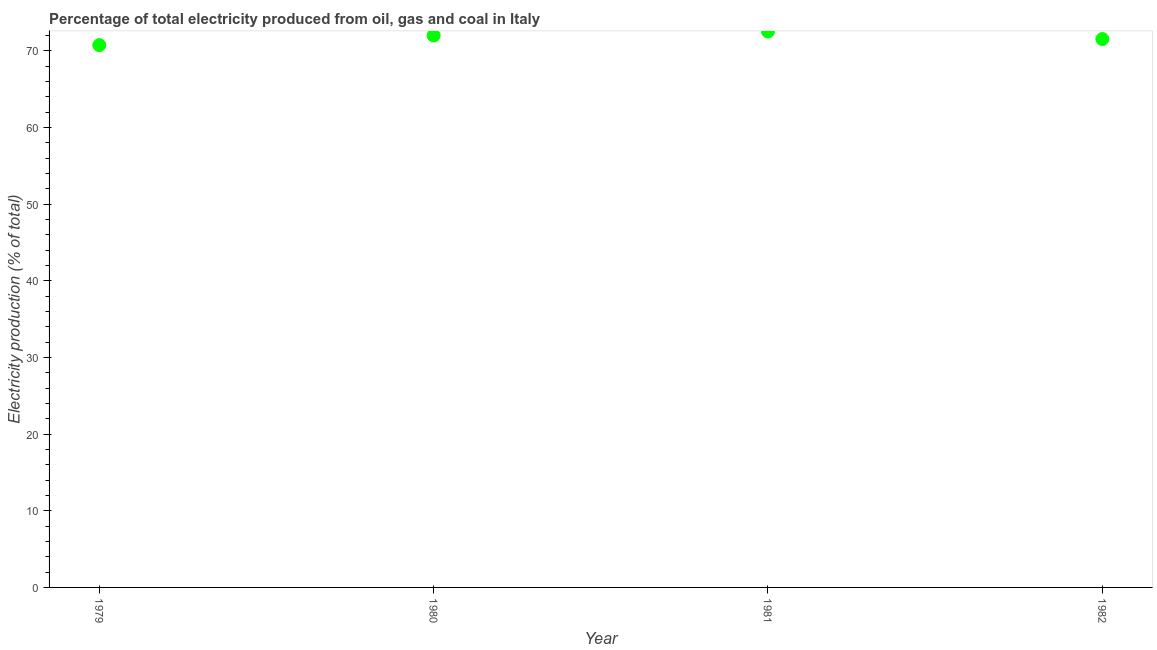What is the electricity production in 1982?
Provide a short and direct response. 71.52. Across all years, what is the maximum electricity production?
Provide a short and direct response. 72.5. Across all years, what is the minimum electricity production?
Provide a short and direct response. 70.73. In which year was the electricity production maximum?
Provide a succinct answer. 1981. In which year was the electricity production minimum?
Your answer should be very brief. 1979. What is the sum of the electricity production?
Your answer should be very brief. 286.72. What is the difference between the electricity production in 1980 and 1982?
Your response must be concise. 0.46. What is the average electricity production per year?
Provide a succinct answer. 71.68. What is the median electricity production?
Your answer should be compact. 71.75. What is the ratio of the electricity production in 1980 to that in 1981?
Offer a terse response. 0.99. What is the difference between the highest and the second highest electricity production?
Offer a terse response. 0.52. What is the difference between the highest and the lowest electricity production?
Provide a succinct answer. 1.78. In how many years, is the electricity production greater than the average electricity production taken over all years?
Your answer should be compact. 2. Does the electricity production monotonically increase over the years?
Keep it short and to the point. No. How many dotlines are there?
Ensure brevity in your answer.  1. Are the values on the major ticks of Y-axis written in scientific E-notation?
Keep it short and to the point. No. What is the title of the graph?
Give a very brief answer. Percentage of total electricity produced from oil, gas and coal in Italy. What is the label or title of the X-axis?
Make the answer very short. Year. What is the label or title of the Y-axis?
Provide a succinct answer. Electricity production (% of total). What is the Electricity production (% of total) in 1979?
Offer a very short reply. 70.73. What is the Electricity production (% of total) in 1980?
Your answer should be very brief. 71.98. What is the Electricity production (% of total) in 1981?
Provide a succinct answer. 72.5. What is the Electricity production (% of total) in 1982?
Give a very brief answer. 71.52. What is the difference between the Electricity production (% of total) in 1979 and 1980?
Provide a succinct answer. -1.25. What is the difference between the Electricity production (% of total) in 1979 and 1981?
Provide a succinct answer. -1.78. What is the difference between the Electricity production (% of total) in 1979 and 1982?
Give a very brief answer. -0.79. What is the difference between the Electricity production (% of total) in 1980 and 1981?
Offer a very short reply. -0.52. What is the difference between the Electricity production (% of total) in 1980 and 1982?
Offer a terse response. 0.46. What is the difference between the Electricity production (% of total) in 1981 and 1982?
Your answer should be compact. 0.98. What is the ratio of the Electricity production (% of total) in 1980 to that in 1982?
Provide a succinct answer. 1.01. 